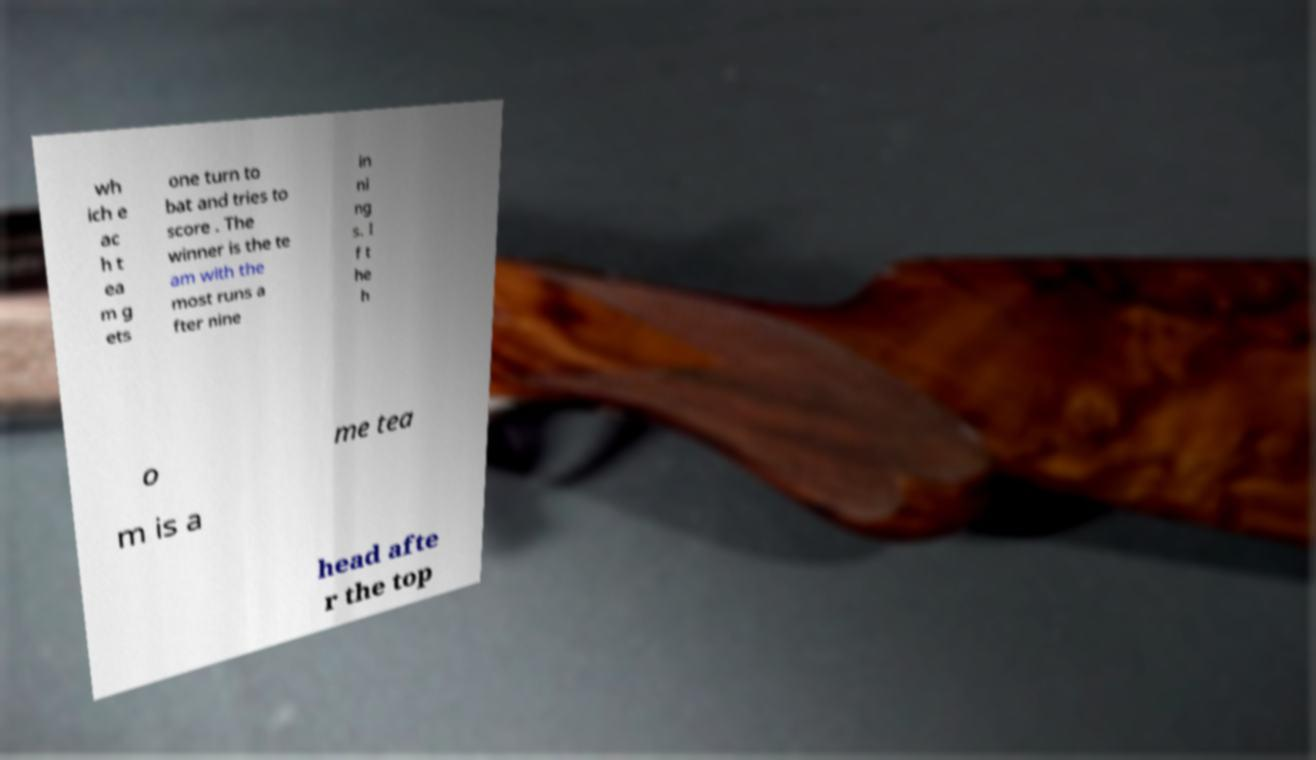Please read and relay the text visible in this image. What does it say? wh ich e ac h t ea m g ets one turn to bat and tries to score . The winner is the te am with the most runs a fter nine in ni ng s. I f t he h o me tea m is a head afte r the top 